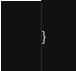<code> <loc_0><loc_0><loc_500><loc_500><_Kotlin_>}</code> 